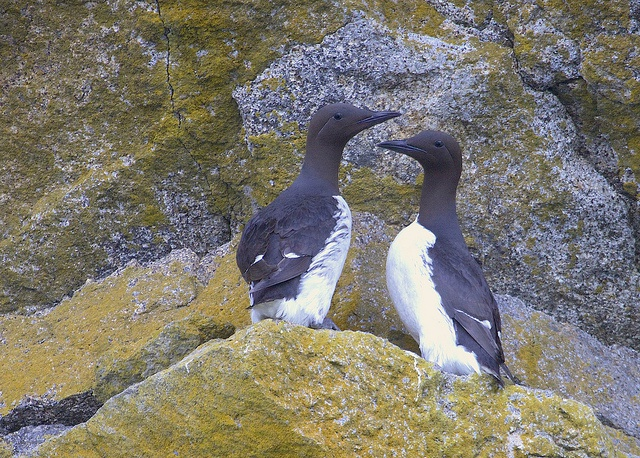Describe the objects in this image and their specific colors. I can see bird in gray, white, and black tones and bird in gray, purple, lightgray, and black tones in this image. 